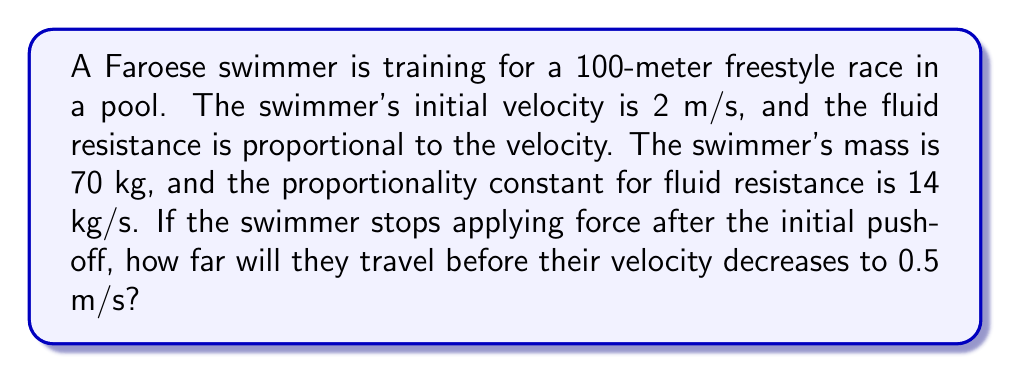Solve this math problem. Let's approach this problem step by step:

1) First, we need to set up our differential equation. Let $v$ be the velocity of the swimmer and $x$ be the distance traveled. The fluid resistance force is proportional to velocity, so we can write:

   $$F = -kv$$

   where $k$ is the proportionality constant.

2) Using Newton's Second Law, $F = ma$, we can write:

   $$-kv = m\frac{dv}{dt}$$

3) Rearranging this equation:

   $$\frac{dv}{dt} = -\frac{k}{m}v$$

4) This is our first-order differential equation. We're given that $m = 70$ kg and $k = 14$ kg/s. Substituting these values:

   $$\frac{dv}{dt} = -\frac{14}{70}v = -0.2v$$

5) To solve this, we can separate variables:

   $$\frac{dv}{v} = -0.2dt$$

6) Integrating both sides:

   $$\int\frac{dv}{v} = \int-0.2dt$$
   $$\ln|v| = -0.2t + C$$

7) Using the initial condition $v(0) = 2$ m/s, we can solve for $C$:

   $$\ln(2) = C$$

8) So our solution is:

   $$\ln|v| = -0.2t + \ln(2)$$
   $$v = 2e^{-0.2t}$$

9) Now, we need to find $t$ when $v = 0.5$ m/s:

   $$0.5 = 2e^{-0.2t}$$
   $$0.25 = e^{-0.2t}$$
   $$\ln(0.25) = -0.2t$$
   $$t = \frac{\ln(4)}{0.2} \approx 6.93\text{ s}$$

10) To find the distance traveled, we need to integrate velocity with respect to time:

    $$x = \int_0^{6.93} 2e^{-0.2t} dt$$
    $$x = -10e^{-0.2t}\Big|_0^{6.93}$$
    $$x = -10(e^{-1.386} - 1) \approx 7.5\text{ m}$$

Therefore, the swimmer will travel approximately 7.5 meters before their velocity decreases to 0.5 m/s.
Answer: The swimmer will travel approximately 7.5 meters before their velocity decreases to 0.5 m/s. 